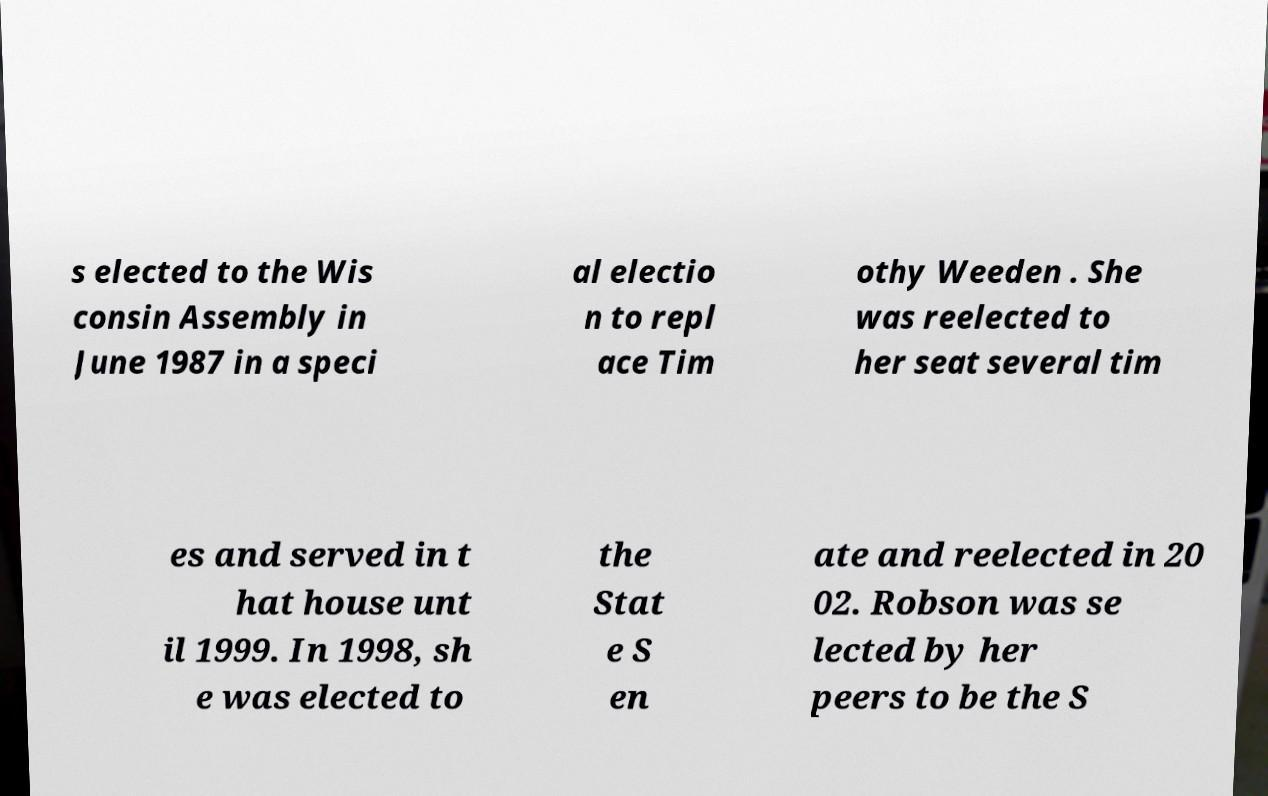Could you extract and type out the text from this image? s elected to the Wis consin Assembly in June 1987 in a speci al electio n to repl ace Tim othy Weeden . She was reelected to her seat several tim es and served in t hat house unt il 1999. In 1998, sh e was elected to the Stat e S en ate and reelected in 20 02. Robson was se lected by her peers to be the S 